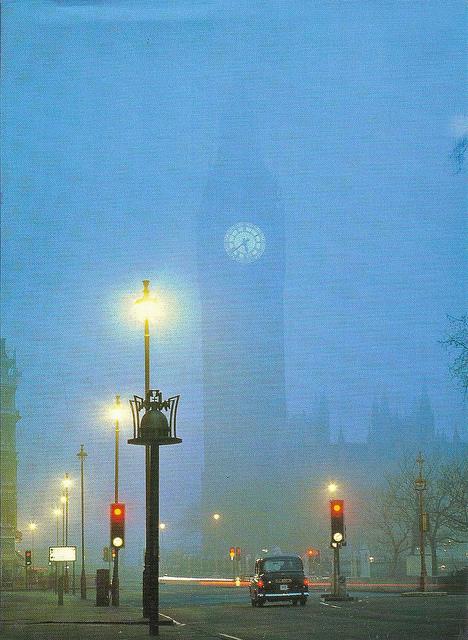How many street lights are there?
Answer briefly. 10. Is that a giant clock?
Write a very short answer. Yes. What is on the side of the street?
Be succinct. Sidewalk. Is it foggy out?
Write a very short answer. Yes. 